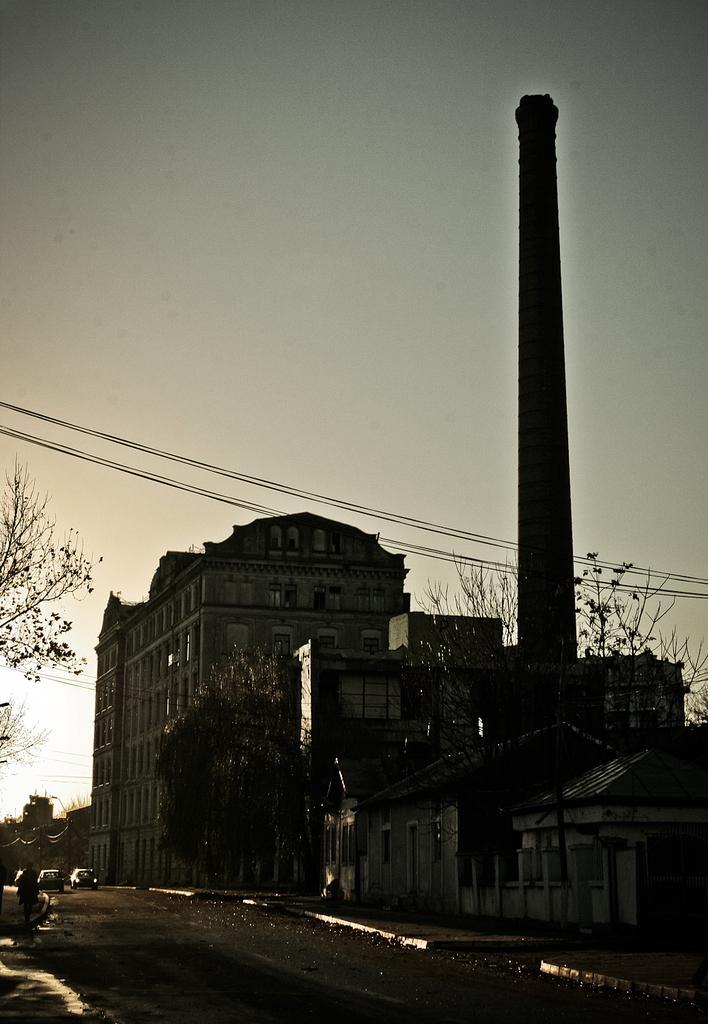How would you summarize this image in a sentence or two? In this image, we can see some trees and buildings. There is a tower on the right side of the image. There is a road at the bottom of the image. There is a sky at the top of the image. 